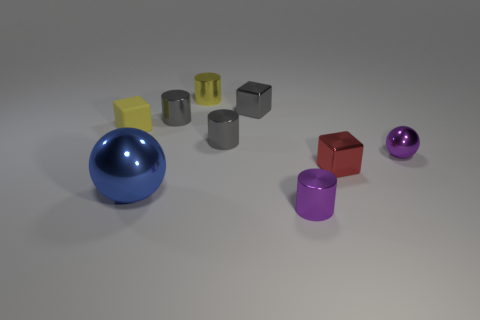Subtract all cylinders. How many objects are left? 5 Add 4 green cubes. How many green cubes exist? 4 Subtract 0 purple cubes. How many objects are left? 9 Subtract all tiny purple cylinders. Subtract all large purple metallic objects. How many objects are left? 8 Add 3 purple things. How many purple things are left? 5 